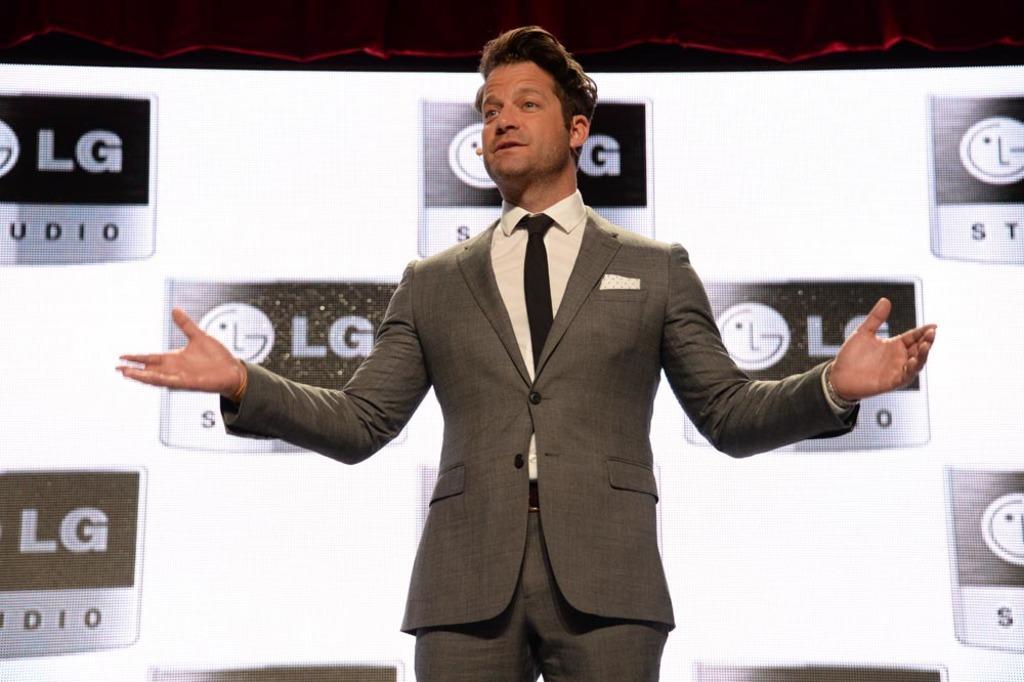In one or two sentences, can you explain what this image depicts? In the picture I can see a man in the middle of the image and he is speaking on a microphone. He is wearing a suit and a tie. In the background, I can see the screen. There is a red color curtain at the top of the image. 